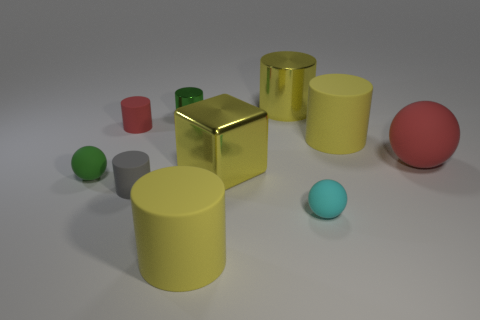The other object that is the same color as the tiny metal thing is what size?
Make the answer very short. Small. Are there any big matte cylinders that have the same color as the cube?
Your response must be concise. Yes. How many other things are the same size as the yellow metal cube?
Make the answer very short. 4. What number of tiny things are brown metal cylinders or metal cubes?
Keep it short and to the point. 0. There is a green sphere; is it the same size as the green thing that is on the right side of the small red rubber cylinder?
Your response must be concise. Yes. How many other objects are the same shape as the big red matte thing?
Your answer should be very brief. 2. What is the shape of the tiny green thing that is the same material as the yellow block?
Your answer should be compact. Cylinder. Are any large things visible?
Your answer should be compact. Yes. Is the number of big metallic blocks behind the big red ball less than the number of yellow rubber cylinders behind the large yellow cube?
Your answer should be compact. Yes. There is a small rubber object that is behind the red sphere; what shape is it?
Offer a terse response. Cylinder. 